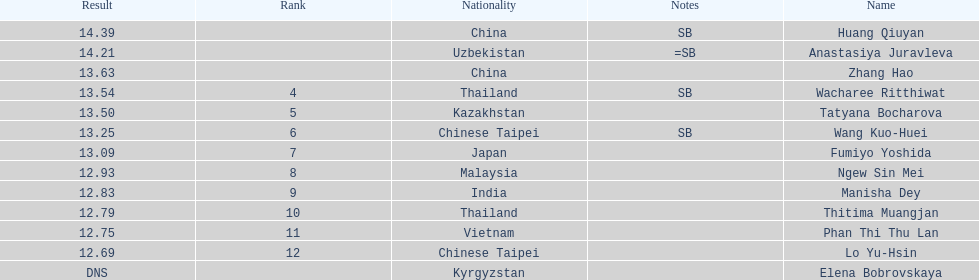What was the mean outcome of the top three leapers? 14.08. 